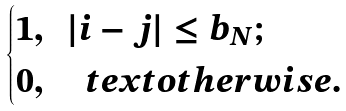<formula> <loc_0><loc_0><loc_500><loc_500>\begin{cases} 1 , \ \ | i - j | \leq b _ { N } ; \\ 0 , \quad t e x t { o t h e r w i s e . } \end{cases}</formula> 